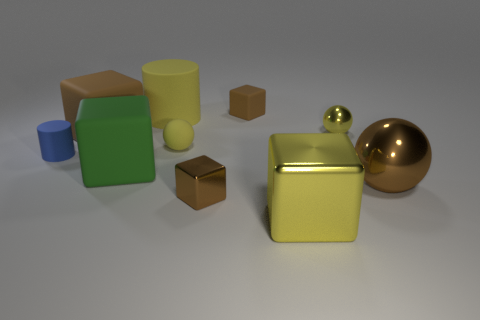Subtract all brown blocks. How many were subtracted if there are1brown blocks left? 2 Subtract all tiny yellow rubber balls. How many balls are left? 2 Subtract all blue blocks. How many yellow balls are left? 2 Subtract all cylinders. How many objects are left? 8 Subtract all yellow blocks. How many blocks are left? 4 Subtract all big yellow metallic cylinders. Subtract all brown spheres. How many objects are left? 9 Add 4 green matte blocks. How many green matte blocks are left? 5 Add 8 large green objects. How many large green objects exist? 9 Subtract 1 yellow cylinders. How many objects are left? 9 Subtract 3 blocks. How many blocks are left? 2 